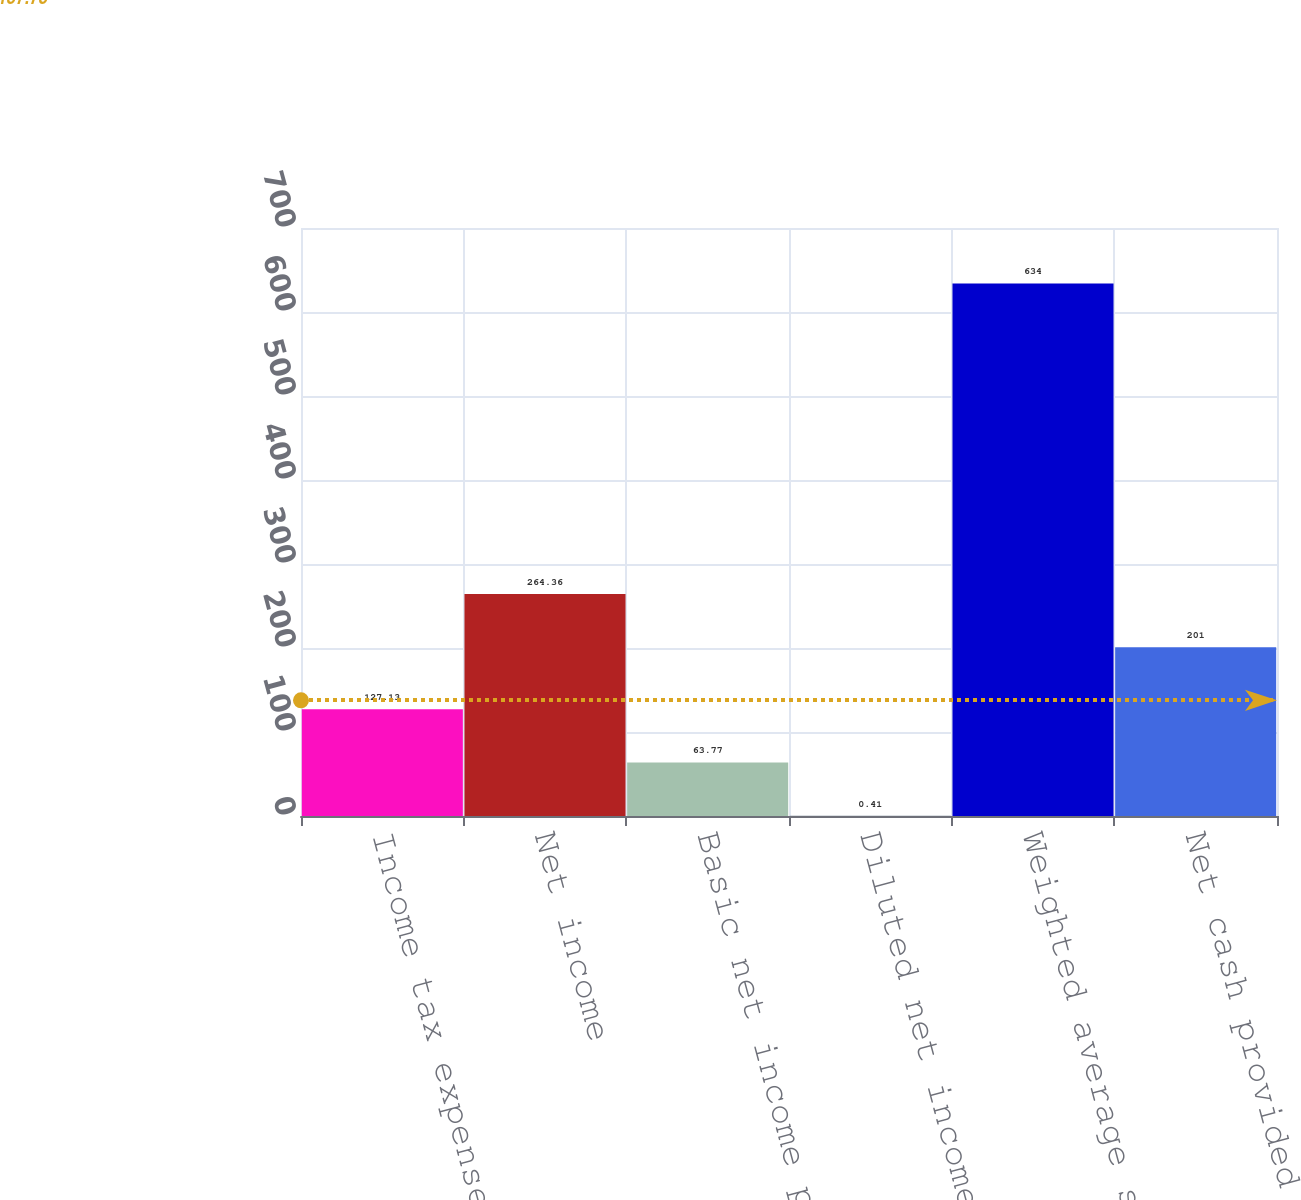Convert chart. <chart><loc_0><loc_0><loc_500><loc_500><bar_chart><fcel>Income tax expense<fcel>Net income<fcel>Basic net income per share<fcel>Diluted net income per share<fcel>Weighted average shares used<fcel>Net cash provided by operating<nl><fcel>127.13<fcel>264.36<fcel>63.77<fcel>0.41<fcel>634<fcel>201<nl></chart> 